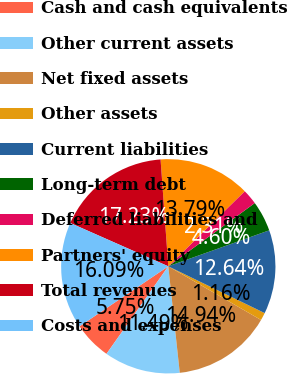Convert chart to OTSL. <chart><loc_0><loc_0><loc_500><loc_500><pie_chart><fcel>Cash and cash equivalents<fcel>Other current assets<fcel>Net fixed assets<fcel>Other assets<fcel>Current liabilities<fcel>Long-term debt<fcel>Deferred liabilities and<fcel>Partners' equity<fcel>Total revenues<fcel>Costs and expenses<nl><fcel>5.75%<fcel>11.49%<fcel>14.94%<fcel>1.16%<fcel>12.64%<fcel>4.6%<fcel>2.31%<fcel>13.79%<fcel>17.23%<fcel>16.09%<nl></chart> 